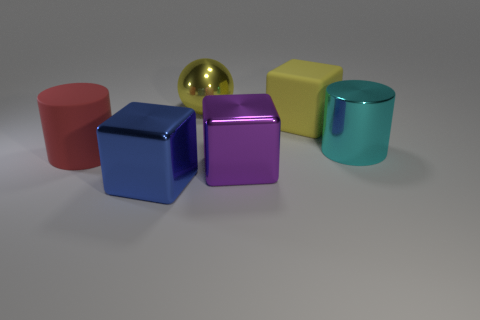Subtract all metallic blocks. How many blocks are left? 1 Subtract all purple blocks. How many blocks are left? 2 Add 2 large yellow balls. How many objects exist? 8 Subtract all cylinders. How many objects are left? 4 Add 3 big red metallic balls. How many big red metallic balls exist? 3 Subtract 0 red balls. How many objects are left? 6 Subtract 1 cylinders. How many cylinders are left? 1 Subtract all blue cylinders. Subtract all red cubes. How many cylinders are left? 2 Subtract all red blocks. How many cyan cylinders are left? 1 Subtract all large green balls. Subtract all big purple things. How many objects are left? 5 